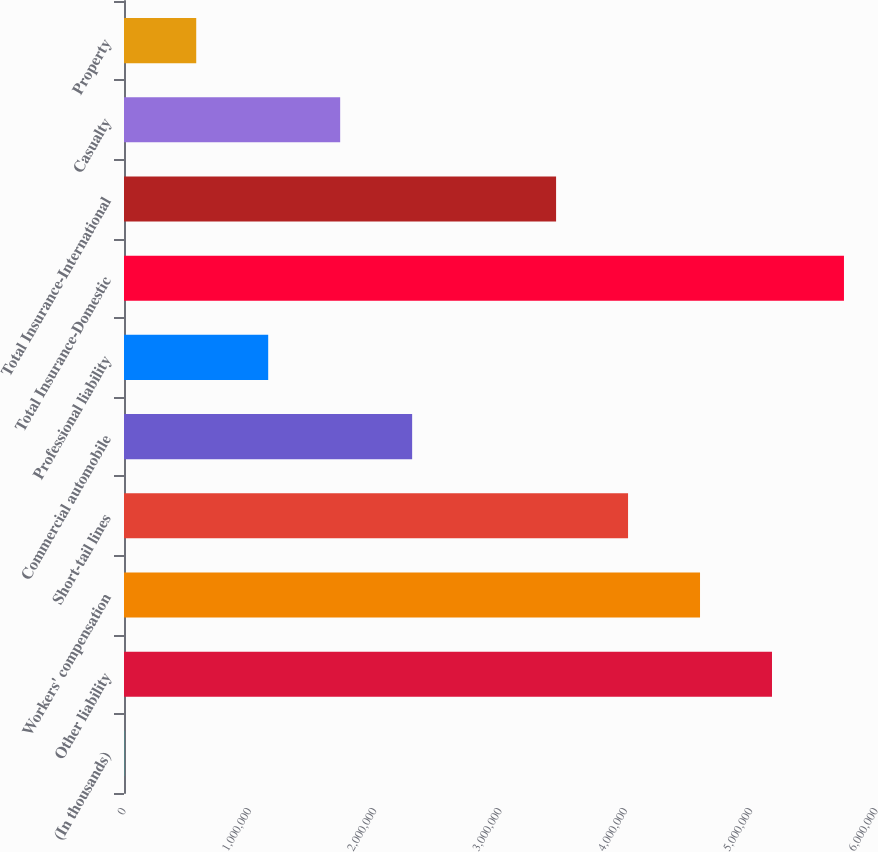Convert chart. <chart><loc_0><loc_0><loc_500><loc_500><bar_chart><fcel>(In thousands)<fcel>Other liability<fcel>Workers' compensation<fcel>Short-tail lines<fcel>Commercial automobile<fcel>Professional liability<fcel>Total Insurance-Domestic<fcel>Total Insurance-International<fcel>Casualty<fcel>Property<nl><fcel>2014<fcel>5.17018e+06<fcel>4.59594e+06<fcel>4.0217e+06<fcel>2.29898e+06<fcel>1.15049e+06<fcel>5.74442e+06<fcel>3.44746e+06<fcel>1.72474e+06<fcel>576254<nl></chart> 